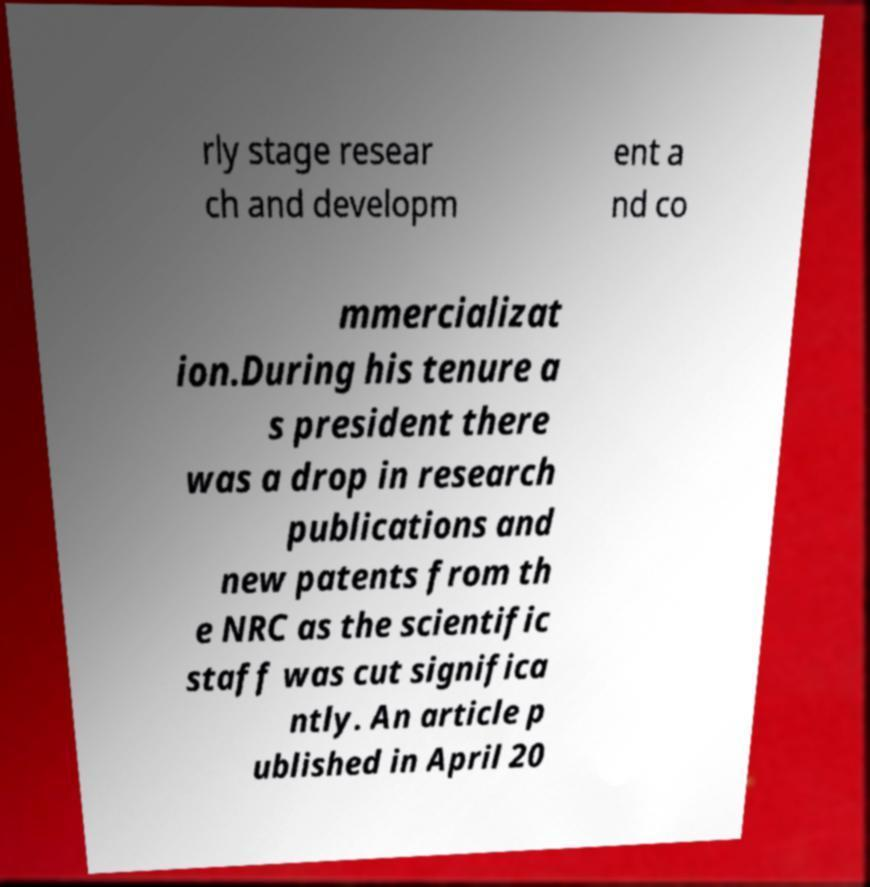What messages or text are displayed in this image? I need them in a readable, typed format. rly stage resear ch and developm ent a nd co mmercializat ion.During his tenure a s president there was a drop in research publications and new patents from th e NRC as the scientific staff was cut significa ntly. An article p ublished in April 20 